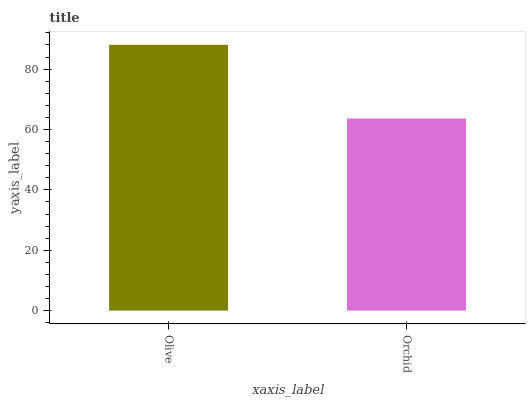Is Orchid the minimum?
Answer yes or no. Yes. Is Olive the maximum?
Answer yes or no. Yes. Is Orchid the maximum?
Answer yes or no. No. Is Olive greater than Orchid?
Answer yes or no. Yes. Is Orchid less than Olive?
Answer yes or no. Yes. Is Orchid greater than Olive?
Answer yes or no. No. Is Olive less than Orchid?
Answer yes or no. No. Is Olive the high median?
Answer yes or no. Yes. Is Orchid the low median?
Answer yes or no. Yes. Is Orchid the high median?
Answer yes or no. No. Is Olive the low median?
Answer yes or no. No. 